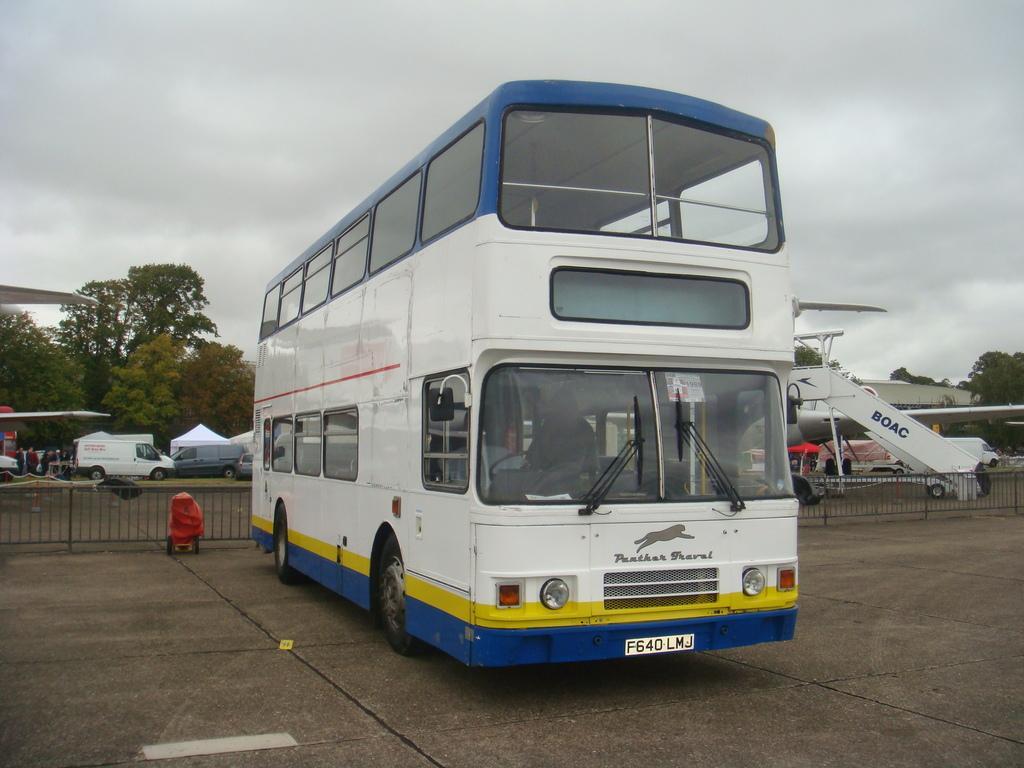Can you describe this image briefly? This picture shows a bus and we see a plane and few vehicles on the side and we see trees and a cloudy Sky. 